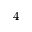<formula> <loc_0><loc_0><loc_500><loc_500>4</formula> 